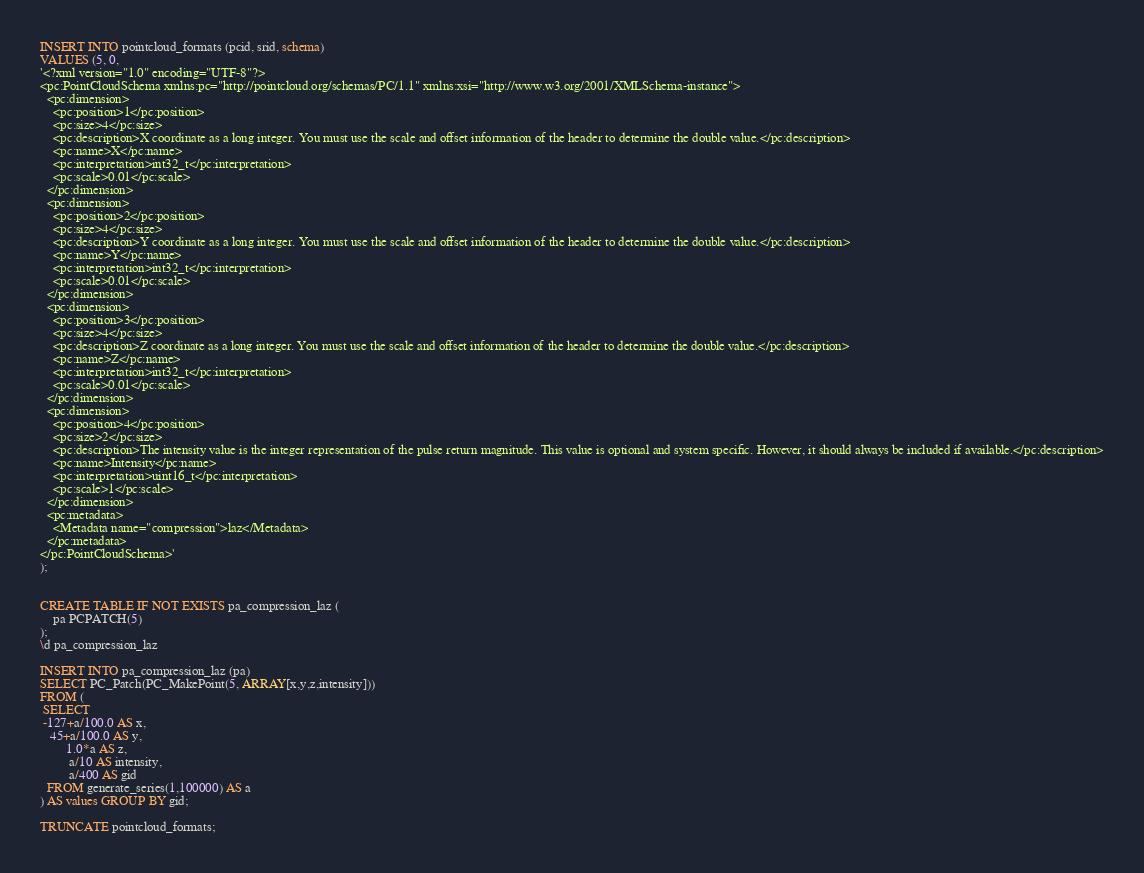<code> <loc_0><loc_0><loc_500><loc_500><_SQL_>
INSERT INTO pointcloud_formats (pcid, srid, schema)
VALUES (5, 0,
'<?xml version="1.0" encoding="UTF-8"?>
<pc:PointCloudSchema xmlns:pc="http://pointcloud.org/schemas/PC/1.1" xmlns:xsi="http://www.w3.org/2001/XMLSchema-instance">
  <pc:dimension>
    <pc:position>1</pc:position>
    <pc:size>4</pc:size>
    <pc:description>X coordinate as a long integer. You must use the scale and offset information of the header to determine the double value.</pc:description>
    <pc:name>X</pc:name>
    <pc:interpretation>int32_t</pc:interpretation>
    <pc:scale>0.01</pc:scale>
  </pc:dimension>
  <pc:dimension>
    <pc:position>2</pc:position>
    <pc:size>4</pc:size>
    <pc:description>Y coordinate as a long integer. You must use the scale and offset information of the header to determine the double value.</pc:description>
    <pc:name>Y</pc:name>
    <pc:interpretation>int32_t</pc:interpretation>
    <pc:scale>0.01</pc:scale>
  </pc:dimension>
  <pc:dimension>
    <pc:position>3</pc:position>
    <pc:size>4</pc:size>
    <pc:description>Z coordinate as a long integer. You must use the scale and offset information of the header to determine the double value.</pc:description>
    <pc:name>Z</pc:name>
    <pc:interpretation>int32_t</pc:interpretation>
    <pc:scale>0.01</pc:scale>
  </pc:dimension>
  <pc:dimension>
    <pc:position>4</pc:position>
    <pc:size>2</pc:size>
    <pc:description>The intensity value is the integer representation of the pulse return magnitude. This value is optional and system specific. However, it should always be included if available.</pc:description>
    <pc:name>Intensity</pc:name>
    <pc:interpretation>uint16_t</pc:interpretation>
    <pc:scale>1</pc:scale>
  </pc:dimension>
  <pc:metadata>
    <Metadata name="compression">laz</Metadata>
  </pc:metadata>
</pc:PointCloudSchema>'
);


CREATE TABLE IF NOT EXISTS pa_compression_laz (
    pa PCPATCH(5)
);
\d pa_compression_laz

INSERT INTO pa_compression_laz (pa)
SELECT PC_Patch(PC_MakePoint(5, ARRAY[x,y,z,intensity]))
FROM (
 SELECT
 -127+a/100.0 AS x,
   45+a/100.0 AS y,
        1.0*a AS z,
         a/10 AS intensity,
         a/400 AS gid
  FROM generate_series(1,100000) AS a
) AS values GROUP BY gid;

TRUNCATE pointcloud_formats;
</code> 